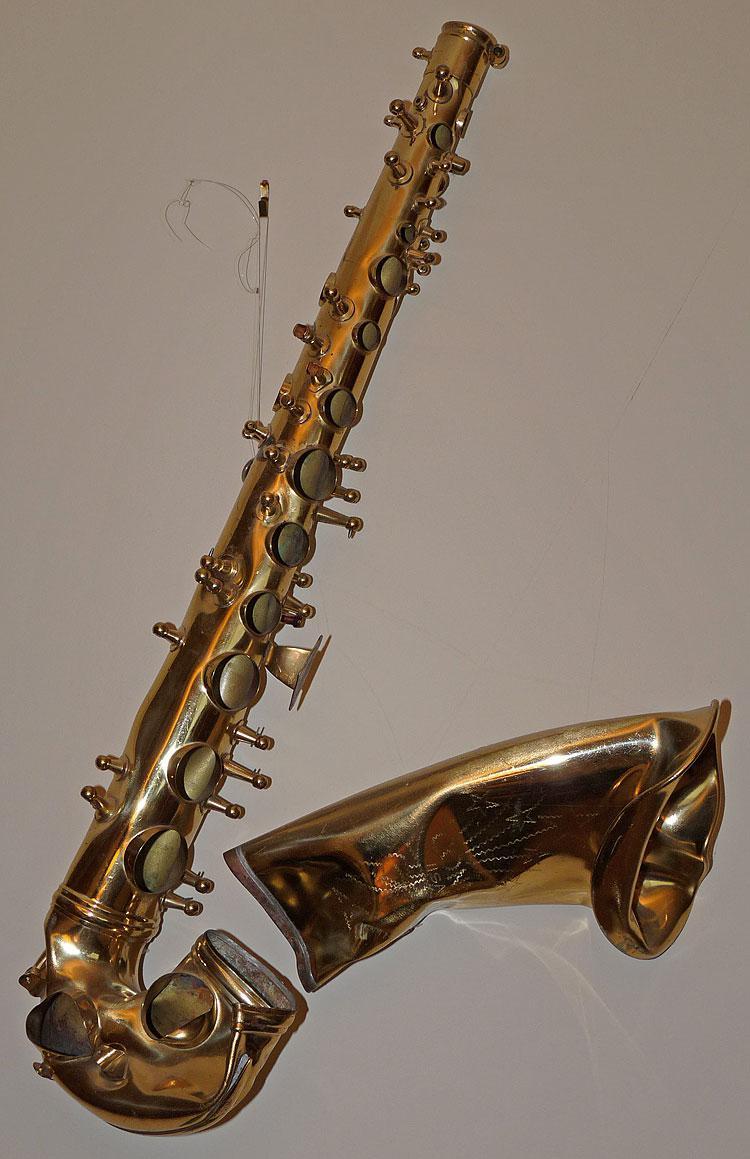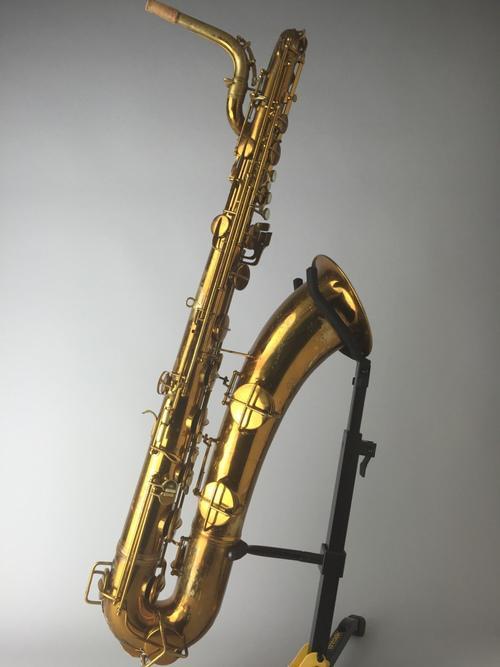The first image is the image on the left, the second image is the image on the right. Assess this claim about the two images: "A saxophone is on a stand in the right image.". Correct or not? Answer yes or no. Yes. 